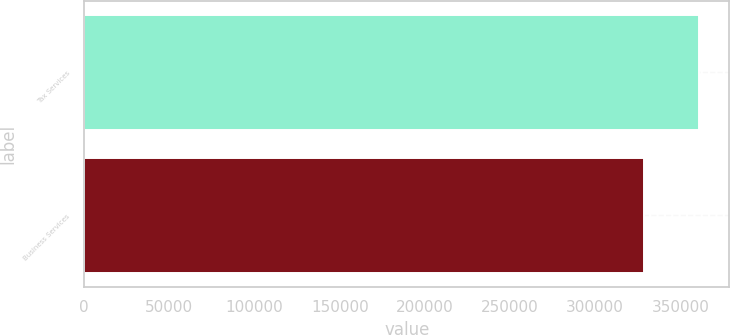Convert chart. <chart><loc_0><loc_0><loc_500><loc_500><bar_chart><fcel>Tax Services<fcel>Business Services<nl><fcel>360781<fcel>328745<nl></chart> 